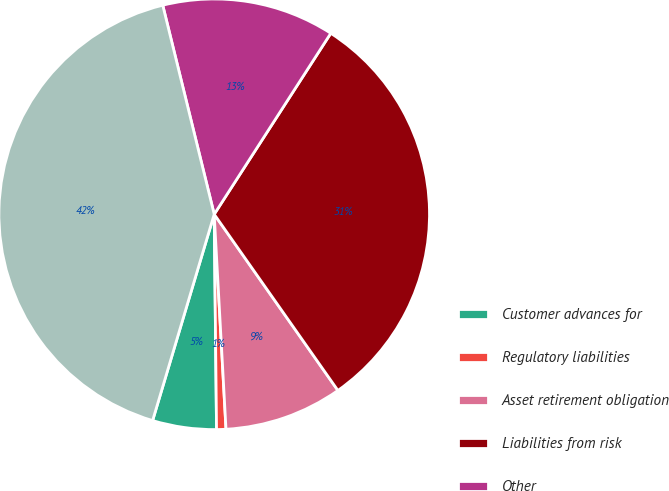Convert chart. <chart><loc_0><loc_0><loc_500><loc_500><pie_chart><fcel>Customer advances for<fcel>Regulatory liabilities<fcel>Asset retirement obligation<fcel>Liabilities from risk<fcel>Other<fcel>Total<nl><fcel>4.79%<fcel>0.7%<fcel>8.87%<fcel>31.15%<fcel>12.95%<fcel>41.54%<nl></chart> 